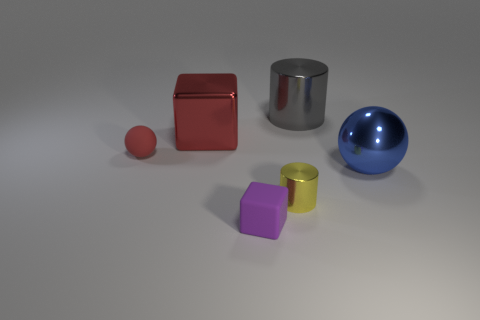Add 3 large red metallic balls. How many objects exist? 9 Add 1 cylinders. How many cylinders are left? 3 Add 2 yellow cubes. How many yellow cubes exist? 2 Subtract 0 cyan cylinders. How many objects are left? 6 Subtract all balls. How many objects are left? 4 Subtract all red shiny things. Subtract all metal cylinders. How many objects are left? 3 